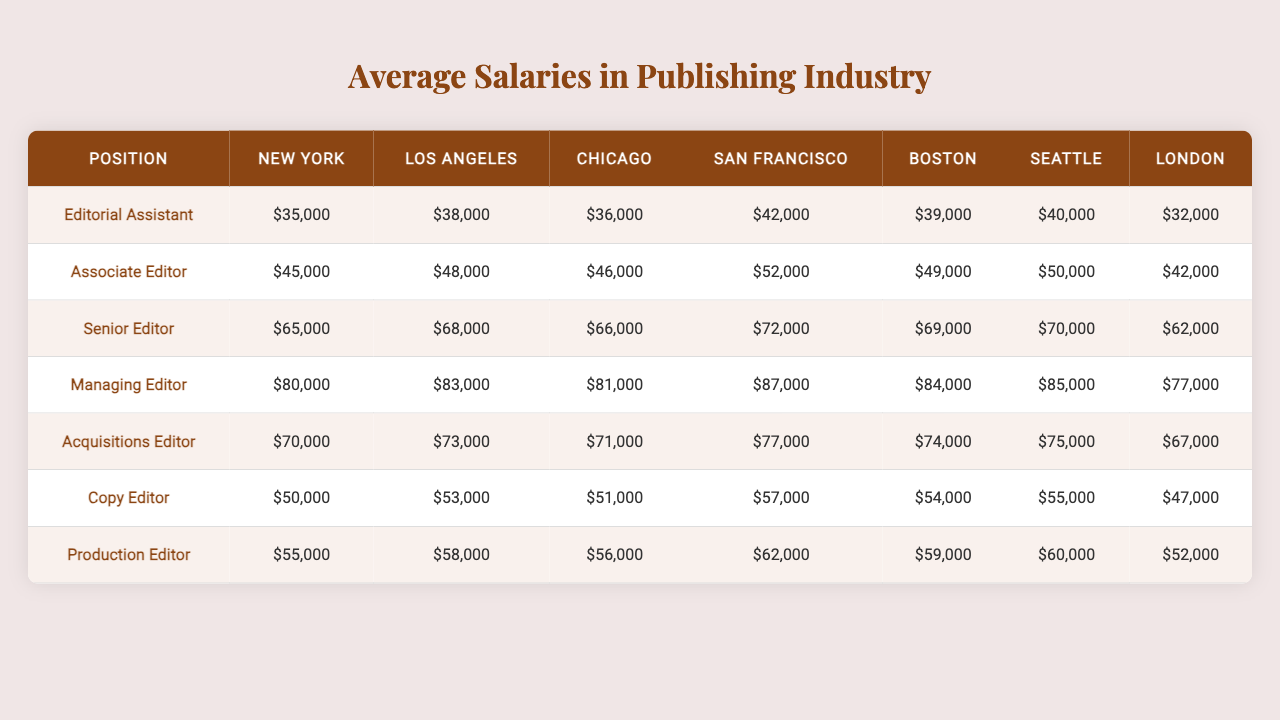What is the average salary of a Copy Editor in New York? The salary for Copy Editors in New York is given directly in the table as $50,000.
Answer: $50,000 Which position has the highest average salary in Los Angeles? By examining the salaries in Los Angeles, the Managing Editor position has the highest average salary of $83,000.
Answer: $83,000 What is the difference in salary between a Senior Editor and an Editorial Assistant in Chicago? The salary for Senior Editors in Chicago is $66,000, and for Editorial Assistants, it's $36,000. The difference is $66,000 - $36,000 = $30,000.
Answer: $30,000 Is the average salary for a Managing Editor in San Francisco greater than $85,000? The salary for Managing Editors in San Francisco is $87,000, which is greater than $85,000.
Answer: Yes What is the median salary for an Acquisitions Editor among all listed cities? To find the median, we look at the salaries for Acquisitions Editors across six cities: $70,000 (NYC), $73,000 (LA), $71,000 (Chicago), $77,000 (SF), $74,000 (Boston), $75,000 (Seattle), $67,000 (London). Arranging them: $67,000, $70,000, $71,000, $73,000, $74,000, $75,000 $77,000. The median is the average of the two middle values: ($73,000 + $74,000)/2 = $73,500.
Answer: $73,500 Which city offers the lowest average salary for a Production Editor? Looking at the salaries for Production Editors, the lowest average is in London at $47,000.
Answer: $47,000 What is the total salary for all positions combined in Boston? In Boston, the salaries are: $39,000 (Editorial Assistant), $49,000 (Associate Editor), $69,000 (Senior Editor), $84,000 (Managing Editor), $74,000 (Acquisitions Editor), $54,000 (Copy Editor), $59,000 (Production Editor). Summing them gives: $39,000 + $49,000 + $69,000 + $84,000 + $74,000 + $54,000 + $59,000 = $428,000.
Answer: $428,000 Which position earns the least on average across all cities? By examining all the salaries, the Editorial Assistant position has the lowest average salary among all listed positions.
Answer: Editorial Assistant What city has the highest average salary for a Copy Editor? In the table, the highest average salary for a Copy Editor is in San Francisco at $57,000.
Answer: San Francisco If we were to rank the positions by salary in Seattle, which comes in second place? The salaries in Seattle are: Editorial Assistant ($40,000), Associate Editor ($50,000), Senior Editor ($70,000), Managing Editor ($85,000), Acquisitions Editor ($75,000), Copy Editor ($55,000), Production Editor ($60,000). Ranking them: 1. Managing Editor, 2. Acquisitions Editor. Therefore, the second position is Acquisitions Editor.
Answer: Acquisitions Editor Are salaries for the Associate Editor position consistent across the cities? By inspecting the salaries for Associate Editors ($48,000 in LA, $46,000 in Chicago, $52,000 in SF, $49,000 in Boston, $50,000 in Seattle, and $42,000 in London), there is variability; thus, they are not consistent.
Answer: No 